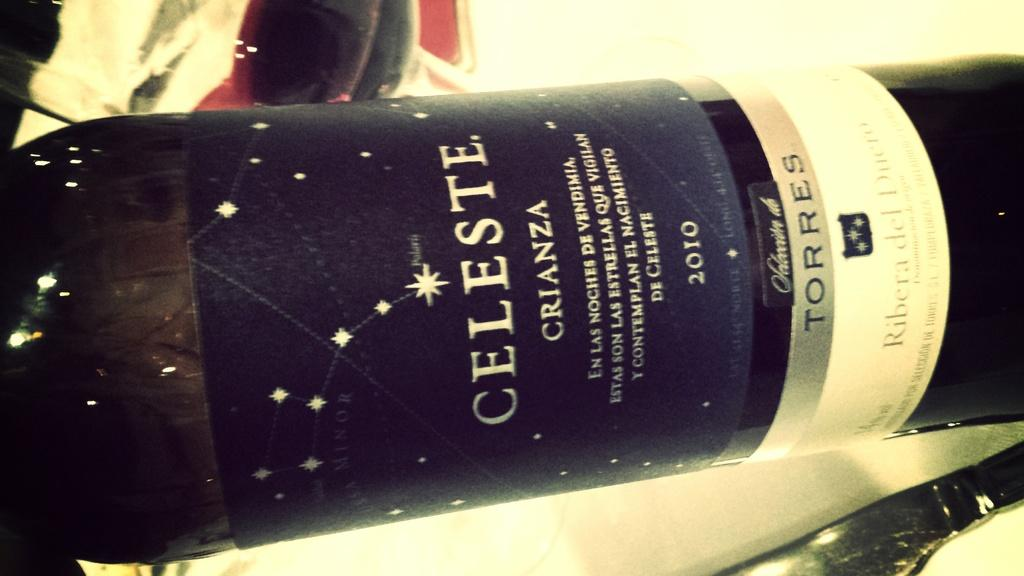<image>
Create a compact narrative representing the image presented. A bottle with a star studded label that reads Celeste Crianza on it. 